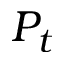<formula> <loc_0><loc_0><loc_500><loc_500>P _ { t }</formula> 